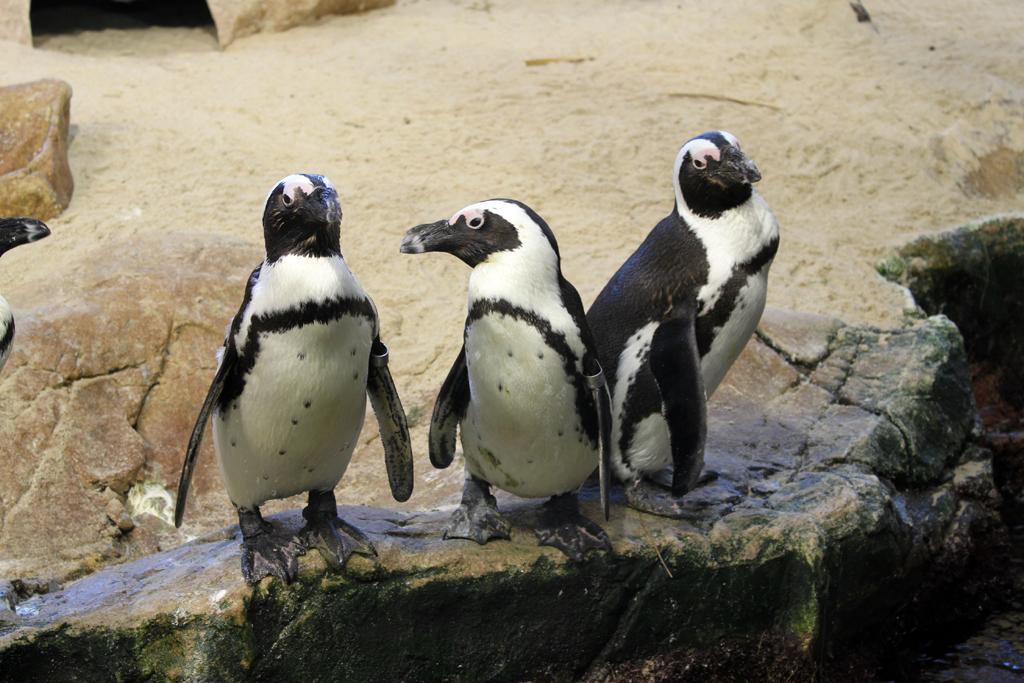In one or two sentences, can you explain what this image depicts? In the center of the image, we can see penguins on the rock. 